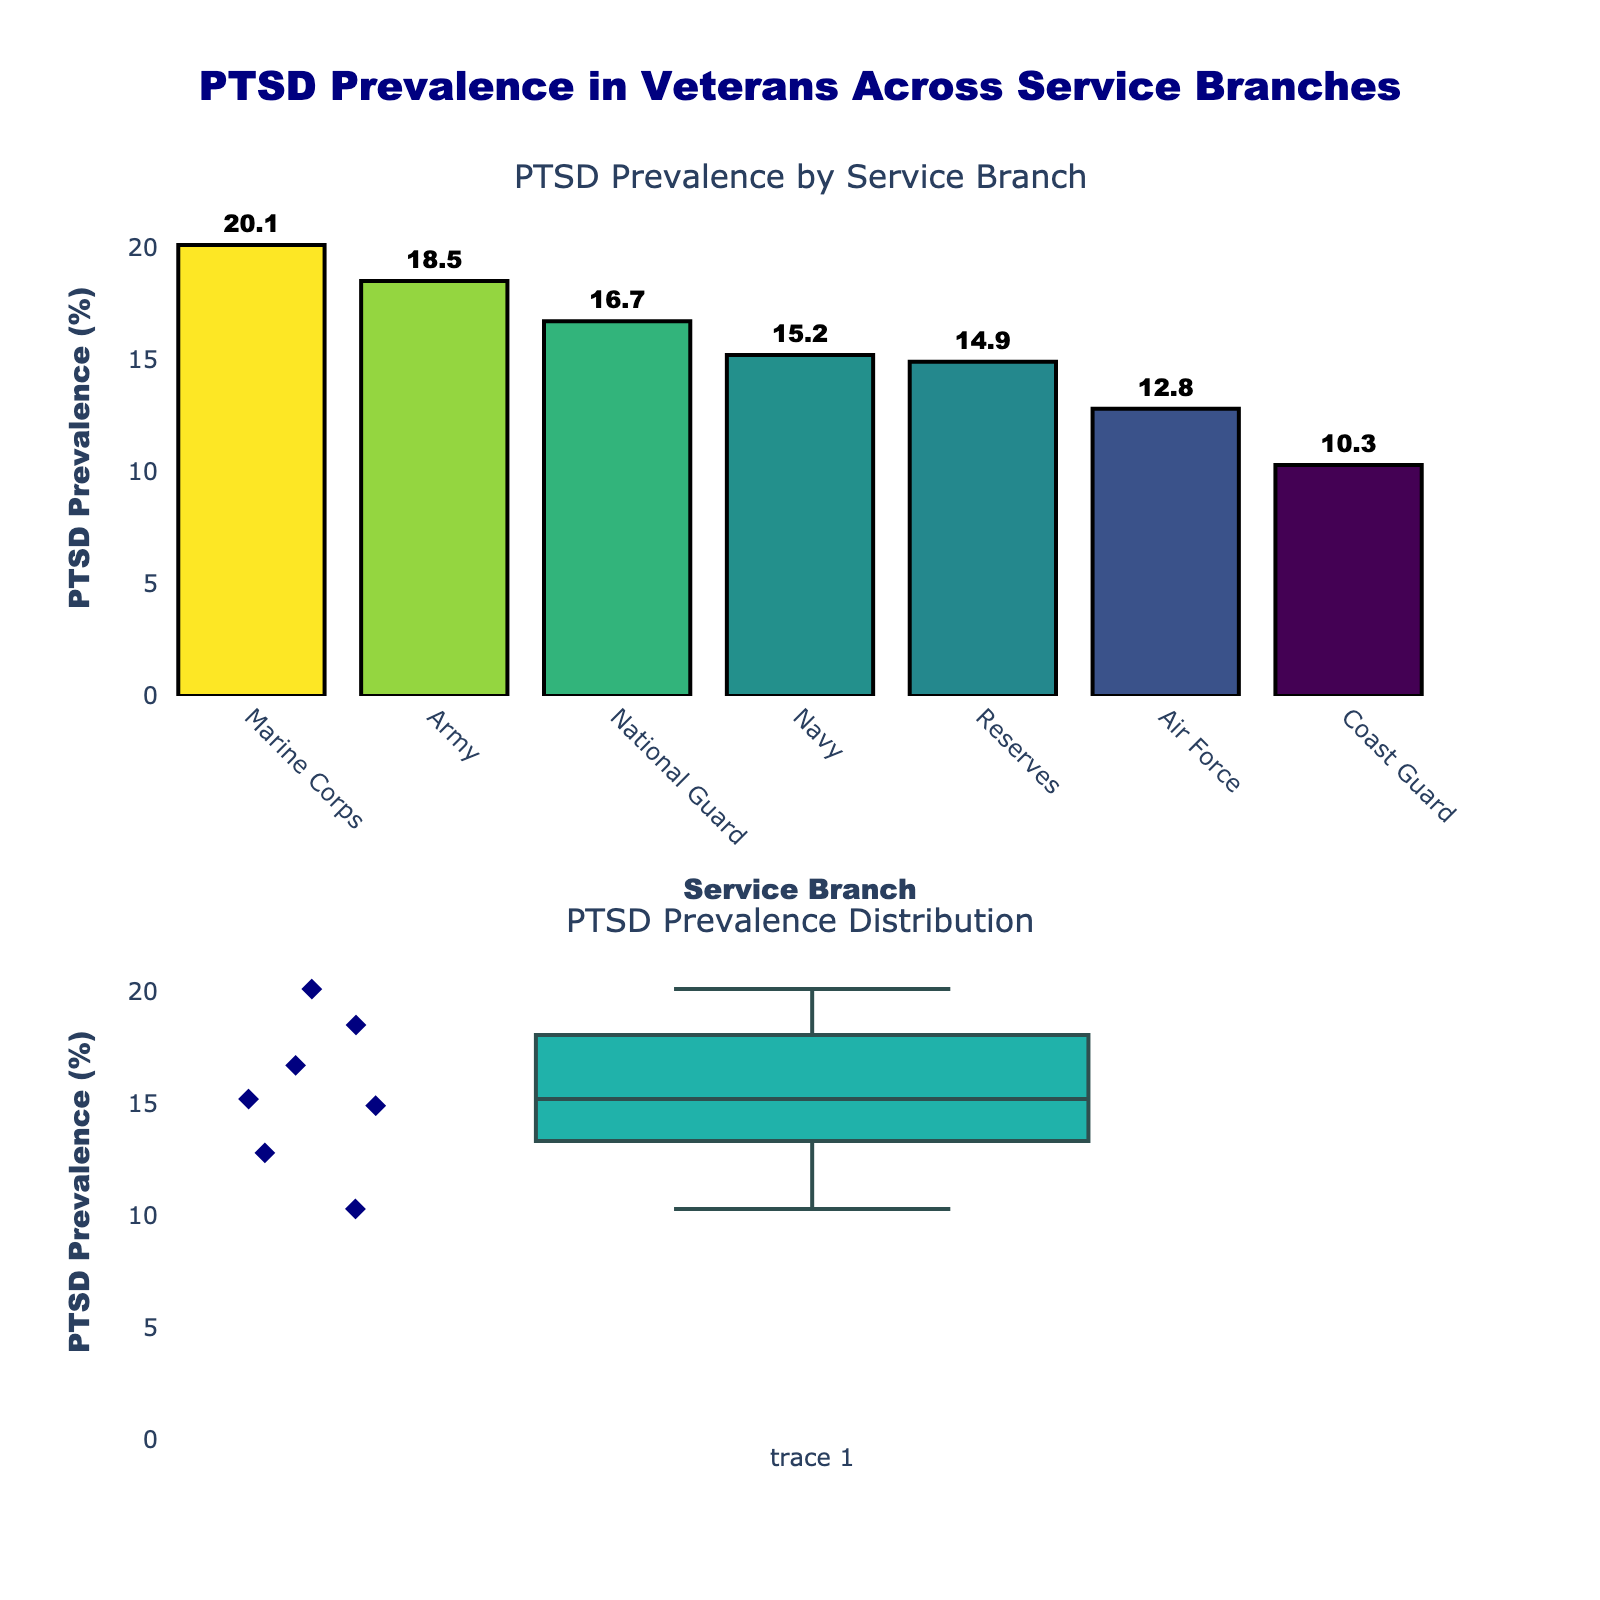What's the title of the vertical subplot figure? The figure's title is prominently positioned at the top center of the image. It is formatted in navy color and a specific font style.
Answer: PTSD Prevalence in Veterans Across Service Branches How many service branches are represented in the bar chart? By counting the unique labels on the x-axis of the bar chart, which are the service branches, we can determine the number of branches.
Answer: 7 Which service branch has the highest prevalence of PTSD symptoms? By observing the height of the bars in the bar chart, we can identify that the Marine Corps bar is the tallest, indicating the highest prevalence.
Answer: Marine Corps What is the PTSD prevalence in the Air Force? By locating the "Air Force" label on the x-axis of the bar chart, we can read the corresponding bar height or the text annotation on top of it.
Answer: 12.8% Compare the PTSD prevalence between the Army and the Navy. Which one is higher and by how much? First, locate the bars for the Army and the Navy. The Army has a prevalence of 18.5%, whereas the Navy has 15.2%. Subtract the Navy's prevalence from the Army's to find the difference.
Answer: The Army has a higher prevalence by 3.3% What’s the range of PTSD prevalence across all service branches? The range is the difference between the maximum and minimum values in the dataset. The maximum prevalence is 20.1% (Marine Corps) and the minimum is 10.3% (Coast Guard). Subtract the minimum from the maximum.
Answer: 9.8% What is the median PTSD prevalence in the dataset? To find the median, list all prevalence values in ascending order: 10.3, 12.8, 14.9, 15.2, 16.7, 18.5, 20.1. The median is the middle value in this ordered list.
Answer: 15.2% Is the PTSD prevalence distribution skewed in any direction? Observe the box plot at the bottom. If the median line inside the box is closer to the bottom or top, it indicates skewness. Also, check for any asymmetry in the whiskers or box.
Answer: Right-skewed (positively skewed) Identify the colors used in the bar chart. The bar chart utilizes a viridis colorscale, ranging from dark purple for lower values to yellow-green for higher values. Each bar's border is black, and text annotations are black.
Answer: Viridis colorscale with black borders and text How does the prevalence of the National Guard compare to the Reserves? By locating the bars for both the National Guard and Reserves, compare their heights or read the specific percentages from the labels. The National Guard has a prevalence of 16.7% and the Reserves have 14.9%.
Answer: The National Guard prevalence is higher by 1.8% 